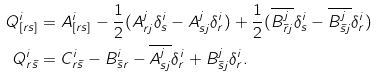<formula> <loc_0><loc_0><loc_500><loc_500>Q ^ { i } _ { [ r s ] } & = A ^ { i } _ { [ r s ] } - \frac { 1 } { 2 } ( A ^ { j } _ { r j } \delta ^ { i } _ { s } - A ^ { j } _ { s j } \delta ^ { i } _ { r } ) + \frac { 1 } { 2 } ( \overline { B ^ { j } _ { \bar { r } j } } \delta ^ { i } _ { s } - \overline { B ^ { j } _ { \bar { s } j } } \delta ^ { i } _ { r } ) \\ Q ^ { i } _ { r \bar { s } } & = C ^ { i } _ { r \bar { s } } - B ^ { i } _ { \bar { s } r } - \overline { A ^ { j } _ { s j } } \delta ^ { i } _ { r } + B ^ { j } _ { \bar { s } j } \delta ^ { i } _ { r } .</formula> 